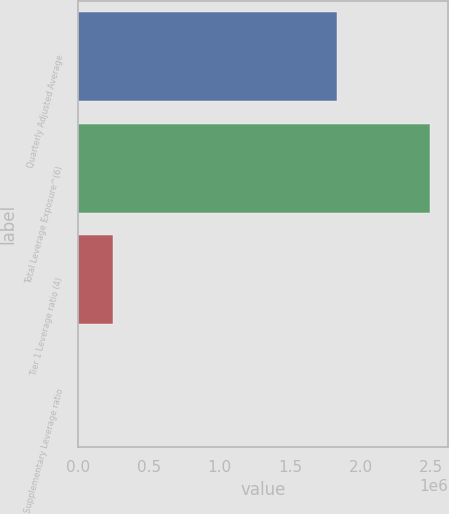<chart> <loc_0><loc_0><loc_500><loc_500><bar_chart><fcel>Quarterly Adjusted Average<fcel>Total Leverage Exposure^(6)<fcel>Tier 1 Leverage ratio (4)<fcel>Supplementary Leverage ratio<nl><fcel>1.83564e+06<fcel>2.49264e+06<fcel>249269<fcel>5.94<nl></chart> 